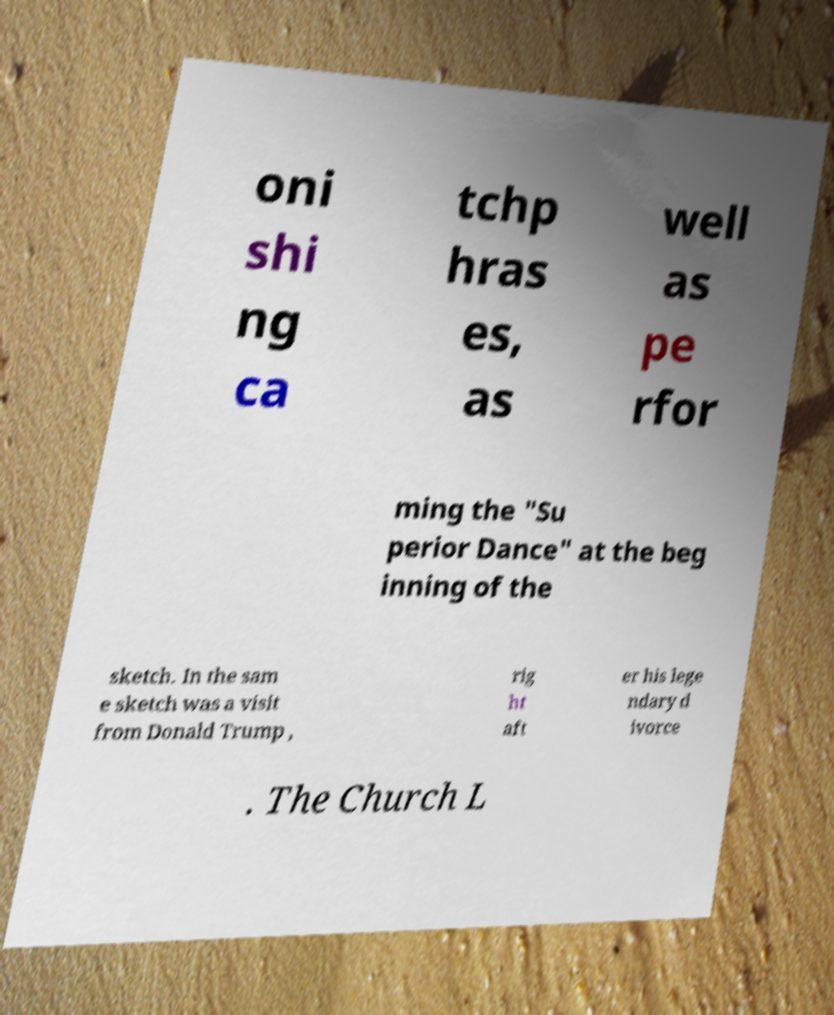I need the written content from this picture converted into text. Can you do that? oni shi ng ca tchp hras es, as well as pe rfor ming the "Su perior Dance" at the beg inning of the sketch. In the sam e sketch was a visit from Donald Trump , rig ht aft er his lege ndary d ivorce . The Church L 